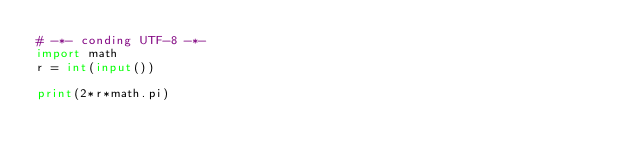<code> <loc_0><loc_0><loc_500><loc_500><_Python_># -*- conding UTF-8 -*-
import math
r = int(input())

print(2*r*math.pi)
</code> 